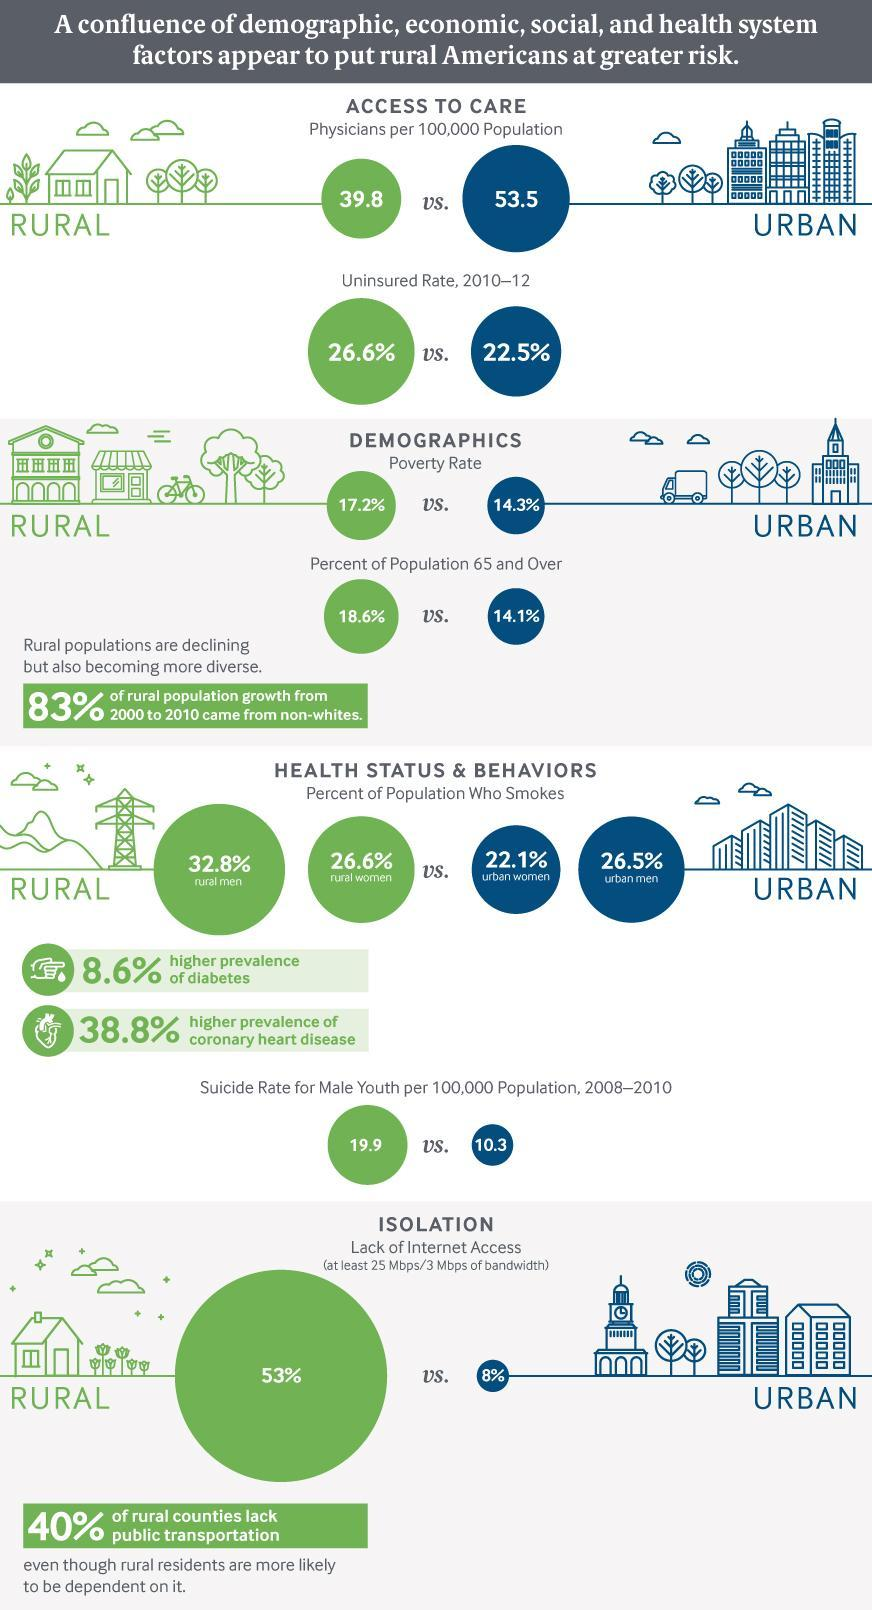What color code is to the Rural population- red, green, blue, black?
Answer the question with a short phrase. green What percentage of the Urban population has internet issues? 8 How many Physicians are available for Urban people if taken a sample of 100,000? 53.5 What color code is to the Urban population- red, green, blue, black? blue What amount of population of urban men do not smoke? 73.5 What amount of population of Urbans have not taken insurance in the period 2010-2012? 22.5% Among the Urban Americans, what amount of the population are Senior Citizens? 14.1% What amount of population of rural women maintain smoke habit? 26.6% What is the self-murder rate among the male youth of the Urban population? 10.3 What amount of population of urban women maintain smoke habit? 22.1% 